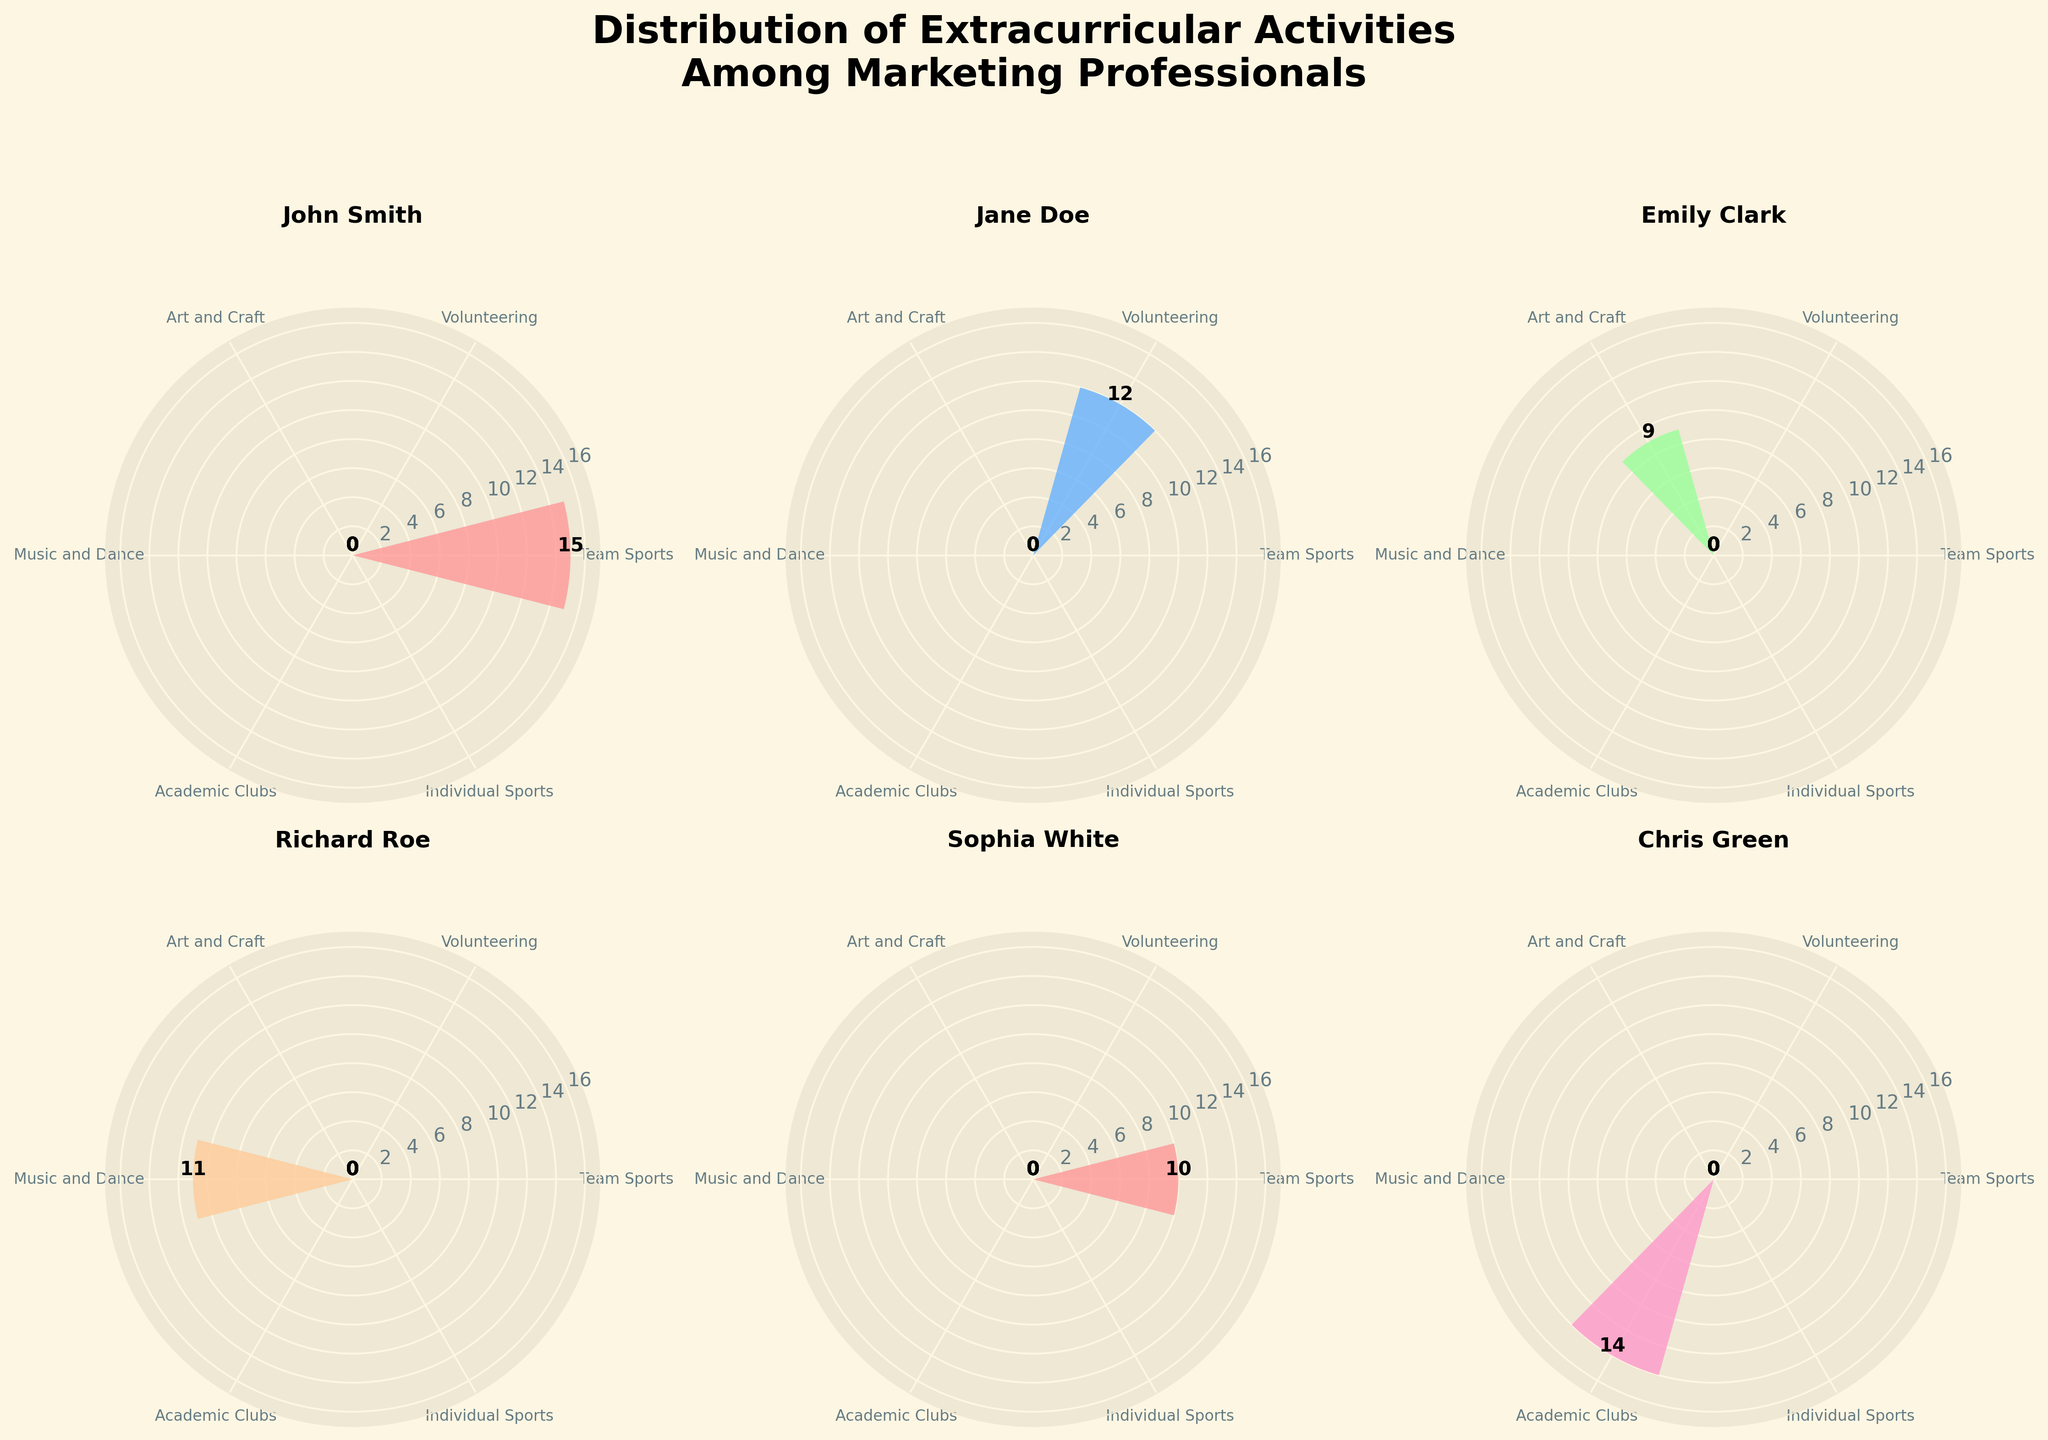Which extracurricular activity has the highest count for John Smith? Look at the subplot titled 'John Smith'. Identify the bar with the highest radii. The bar representing 'Team Sports' has the highest count.
Answer: Team Sports How many categories of extracurricular activities are there in total? Each subplot represents the same categories. Count the distinct labels around any subplot's circumference.
Answer: 6 Which two individuals have the highest and lowest engagement in Music and Dance, respectively, among the first 6 subplots? Check each subplot's bar for 'Music and Dance'. Compare the radii to find the highest and lowest values. Richard Roe has the highest (11) and Olivia Blue has the lowest (7).
Answer: Richard Roe, Olivia Blue What is the sum of counts for Volunteering activities for all individuals shown in the first 6 subplots? Add the counts for 'Volunteering' from each subplot: 12 (Jane Doe), 8 (Megan Brown), 10 (David Purple), 9 (Rebecca Pink), and 0 for John Smith and Emily Clark who don't have Volunteering.
Answer: 39 Who has participated equally in both Academic Clubs and Individual Sports? Check each subplot. Nathan Black shows the same count for 'Academic Clubs' and 'Individual Sports', each with 13 counts. So he is not correct. No one from the first 6 subplots meets this criterion.
Answer: No one Which individual has the most balanced distribution of activities, with counts differing as little as possible across categories? Evaluate each subplot to find the individual with the smallest range between their highest and lowest counts. Look for bars of nearly equal height. Emily Clark's activities are Arts and Crafts (9), with other categories being less or 0 which shows least disparity
Answer: Emily Clark 